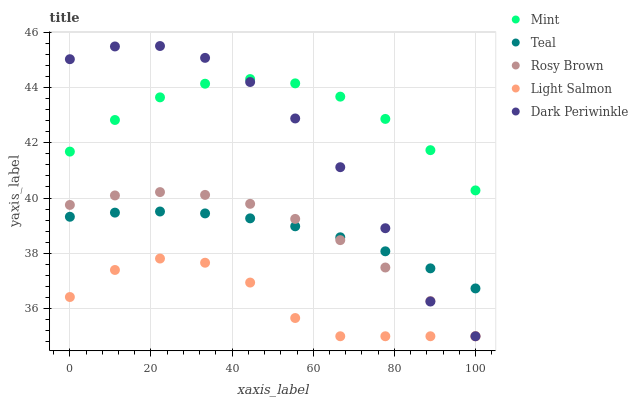Does Light Salmon have the minimum area under the curve?
Answer yes or no. Yes. Does Mint have the maximum area under the curve?
Answer yes or no. Yes. Does Rosy Brown have the minimum area under the curve?
Answer yes or no. No. Does Rosy Brown have the maximum area under the curve?
Answer yes or no. No. Is Teal the smoothest?
Answer yes or no. Yes. Is Dark Periwinkle the roughest?
Answer yes or no. Yes. Is Rosy Brown the smoothest?
Answer yes or no. No. Is Rosy Brown the roughest?
Answer yes or no. No. Does Light Salmon have the lowest value?
Answer yes or no. Yes. Does Mint have the lowest value?
Answer yes or no. No. Does Dark Periwinkle have the highest value?
Answer yes or no. Yes. Does Rosy Brown have the highest value?
Answer yes or no. No. Is Teal less than Mint?
Answer yes or no. Yes. Is Mint greater than Rosy Brown?
Answer yes or no. Yes. Does Mint intersect Dark Periwinkle?
Answer yes or no. Yes. Is Mint less than Dark Periwinkle?
Answer yes or no. No. Is Mint greater than Dark Periwinkle?
Answer yes or no. No. Does Teal intersect Mint?
Answer yes or no. No. 